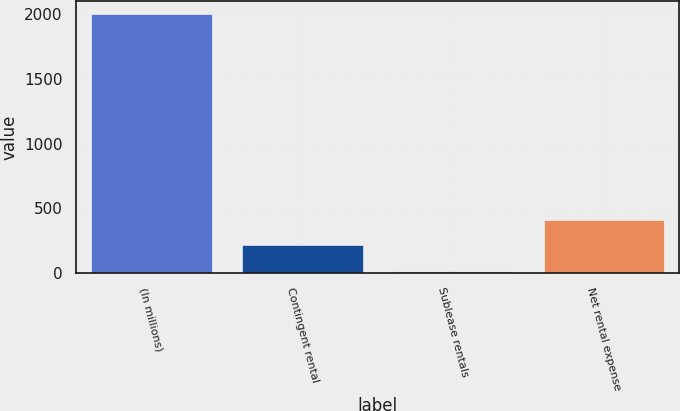Convert chart. <chart><loc_0><loc_0><loc_500><loc_500><bar_chart><fcel>(In millions)<fcel>Contingent rental<fcel>Sublease rentals<fcel>Net rental expense<nl><fcel>2005<fcel>213.1<fcel>14<fcel>412.2<nl></chart> 